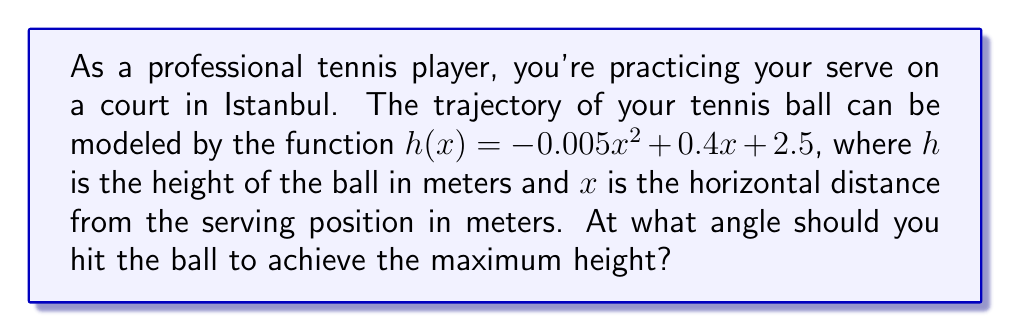What is the answer to this math problem? To find the optimal angle for the tennis shot, we need to determine where the maximum height occurs. This can be done by finding the vertex of the parabola described by the function.

Step 1: The general form of a quadratic function is $f(x) = ax^2 + bx + c$. In this case:
$a = -0.005$
$b = 0.4$
$c = 2.5$

Step 2: For a quadratic function, the x-coordinate of the vertex is given by $x = -\frac{b}{2a}$. Let's calculate this:

$x = -\frac{0.4}{2(-0.005)} = -\frac{0.4}{-0.01} = 40$ meters

Step 3: The maximum height occurs at this x-value. To find the angle, we need to use the derivative of the function at this point.

Step 4: The derivative of $h(x) = -0.005x^2 + 0.4x + 2.5$ is:
$h'(x) = -0.01x + 0.4$

Step 5: Evaluate the derivative at $x = 40$:
$h'(40) = -0.01(40) + 0.4 = 0$

Step 6: The angle of the shot at its highest point is 0°. To find the initial angle, we need to use the inverse tangent function:

$\theta = \arctan(\frac{h'(0)}{1}) = \arctan(0.4)$

Step 7: Convert this to degrees:
$\theta = \arctan(0.4) \approx 21.8°$

Therefore, the optimal angle for the tennis shot to achieve maximum height is approximately 21.8°.
Answer: $21.8°$ 